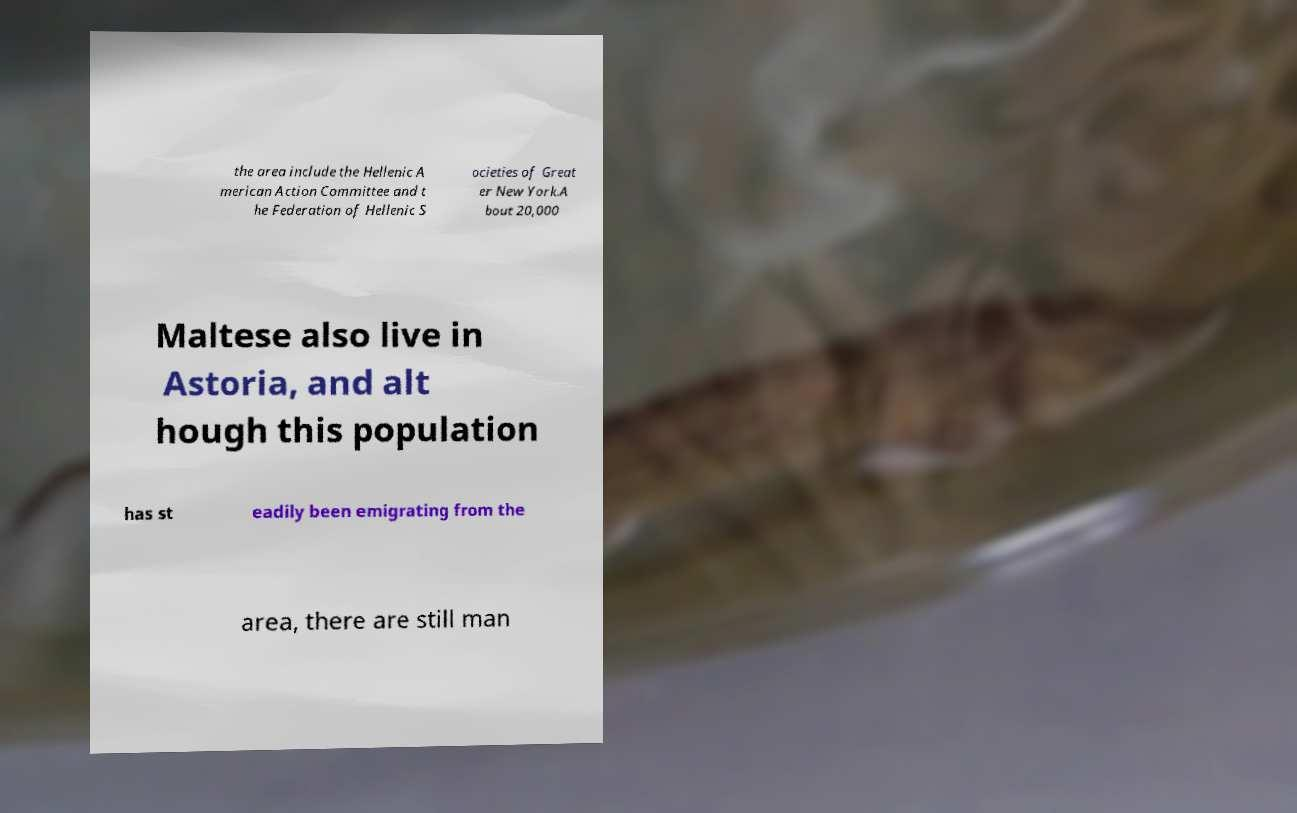For documentation purposes, I need the text within this image transcribed. Could you provide that? the area include the Hellenic A merican Action Committee and t he Federation of Hellenic S ocieties of Great er New York.A bout 20,000 Maltese also live in Astoria, and alt hough this population has st eadily been emigrating from the area, there are still man 